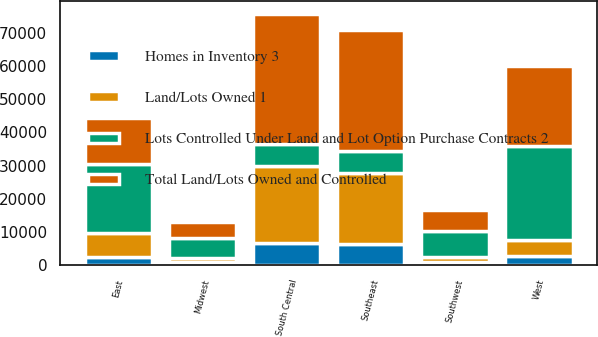Convert chart. <chart><loc_0><loc_0><loc_500><loc_500><stacked_bar_chart><ecel><fcel>East<fcel>Midwest<fcel>Southeast<fcel>South Central<fcel>Southwest<fcel>West<nl><fcel>Total Land/Lots Owned and Controlled<fcel>13700<fcel>5000<fcel>36500<fcel>39200<fcel>6300<fcel>23900<nl><fcel>Land/Lots Owned 1<fcel>7100<fcel>1000<fcel>21400<fcel>23300<fcel>1500<fcel>4600<nl><fcel>Lots Controlled Under Land and Lot Option Purchase Contracts 2<fcel>20800<fcel>6000<fcel>6500<fcel>6500<fcel>7800<fcel>28500<nl><fcel>Homes in Inventory 3<fcel>2600<fcel>1100<fcel>6400<fcel>6600<fcel>1000<fcel>2900<nl></chart> 